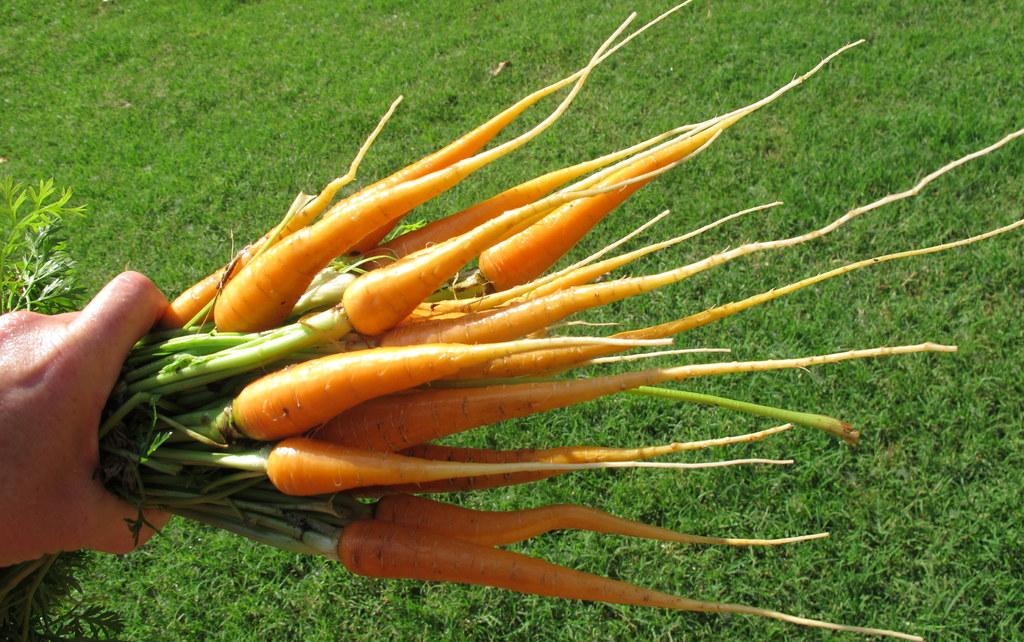What is the person's hand doing in the image? The hand is holding carrots in the image. What can be seen in the background of the image? There is farmland in the background of the image. What type of vegetation is on the right side of the image? There is grass on the right side of the image. What type of ink is being used to draw on the carrots in the image? There is no ink or drawing present on the carrots in the image; the hand is simply holding them. 